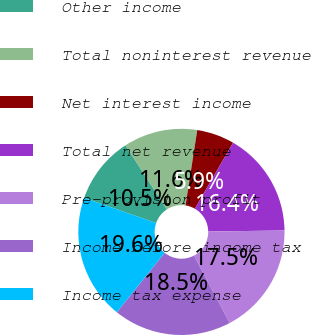Convert chart to OTSL. <chart><loc_0><loc_0><loc_500><loc_500><pie_chart><fcel>Other income<fcel>Total noninterest revenue<fcel>Net interest income<fcel>Total net revenue<fcel>Pre-provision profit<fcel>Income before income tax<fcel>Income tax expense<nl><fcel>10.52%<fcel>11.58%<fcel>5.9%<fcel>16.42%<fcel>17.47%<fcel>18.53%<fcel>19.58%<nl></chart> 